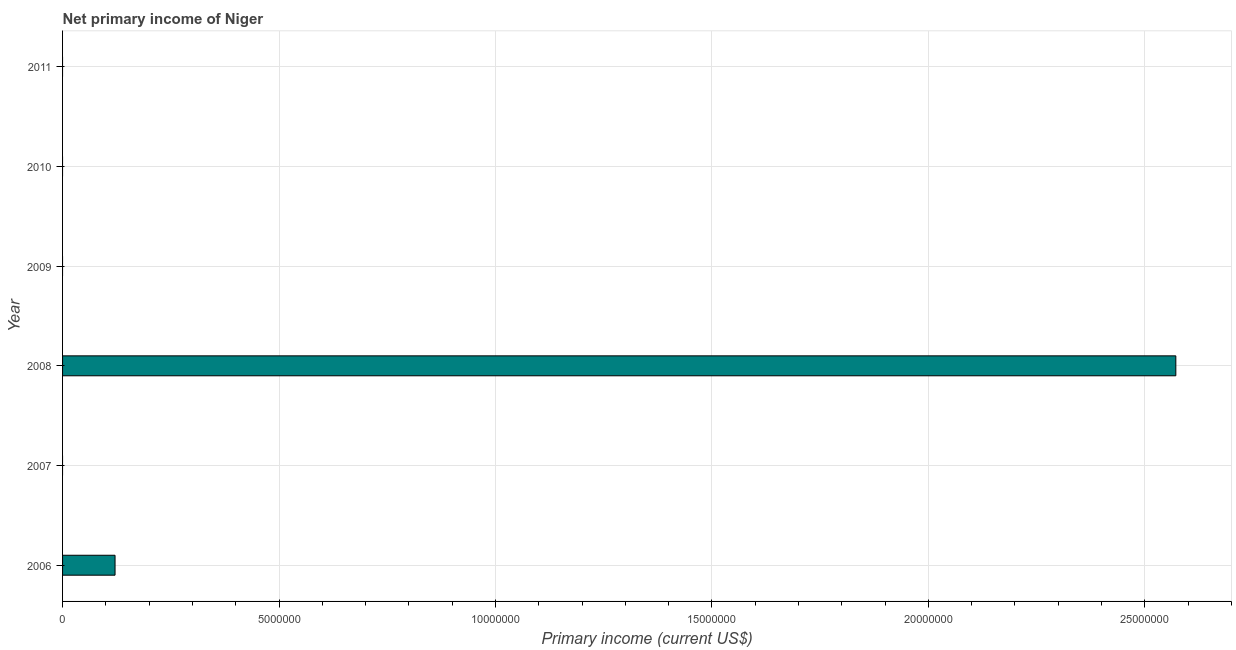Does the graph contain grids?
Ensure brevity in your answer.  Yes. What is the title of the graph?
Offer a terse response. Net primary income of Niger. What is the label or title of the X-axis?
Provide a succinct answer. Primary income (current US$). What is the label or title of the Y-axis?
Keep it short and to the point. Year. What is the amount of primary income in 2009?
Ensure brevity in your answer.  0. Across all years, what is the maximum amount of primary income?
Your response must be concise. 2.57e+07. Across all years, what is the minimum amount of primary income?
Your response must be concise. 0. What is the sum of the amount of primary income?
Your answer should be compact. 2.69e+07. What is the average amount of primary income per year?
Your answer should be compact. 4.49e+06. What is the difference between the highest and the lowest amount of primary income?
Ensure brevity in your answer.  2.57e+07. In how many years, is the amount of primary income greater than the average amount of primary income taken over all years?
Ensure brevity in your answer.  1. How many bars are there?
Make the answer very short. 2. Are all the bars in the graph horizontal?
Offer a terse response. Yes. What is the difference between two consecutive major ticks on the X-axis?
Offer a very short reply. 5.00e+06. Are the values on the major ticks of X-axis written in scientific E-notation?
Ensure brevity in your answer.  No. What is the Primary income (current US$) in 2006?
Make the answer very short. 1.21e+06. What is the Primary income (current US$) in 2007?
Ensure brevity in your answer.  0. What is the Primary income (current US$) of 2008?
Ensure brevity in your answer.  2.57e+07. What is the Primary income (current US$) of 2009?
Provide a succinct answer. 0. What is the Primary income (current US$) in 2011?
Your answer should be compact. 0. What is the difference between the Primary income (current US$) in 2006 and 2008?
Your answer should be very brief. -2.45e+07. What is the ratio of the Primary income (current US$) in 2006 to that in 2008?
Offer a very short reply. 0.05. 